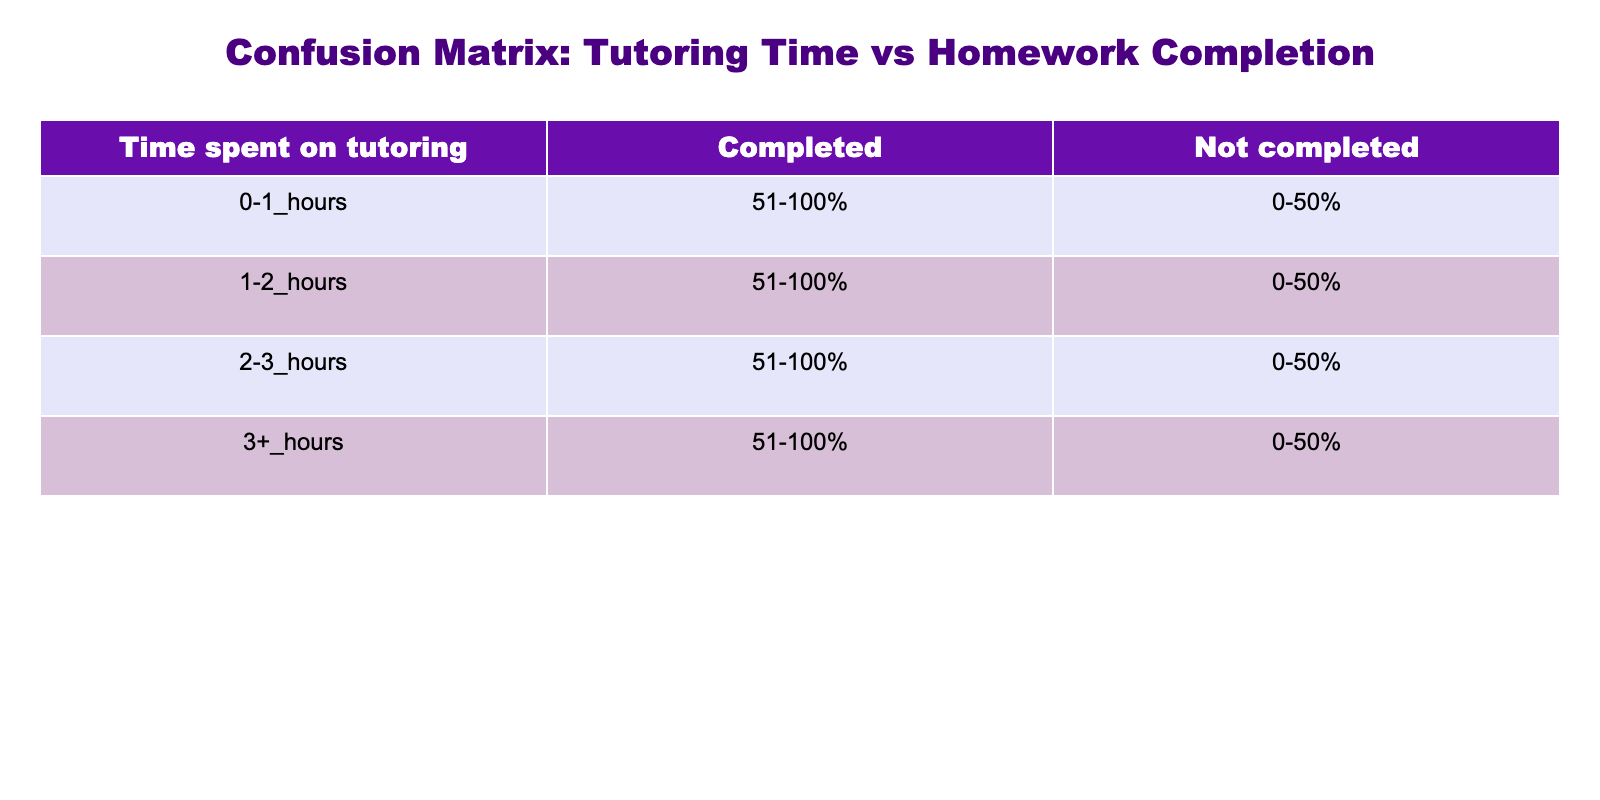What is the homework completion rate for those who spent 0-1 hours on tutoring? According to the table, for the time spent on tutoring of 0-1 hours, the completion rate shows "No" for 0-50% and "Yes" for 51-100%. Thus, the homework completion rates indicate that 0-1 hours of tutoring resulted in both completed and non-completed homework.
Answer: 0-50%: No, 51-100%: Yes How many time intervals have a 'Yes' for homework completion? By examining the table, we count the time intervals for which the Completed column has a 'Yes.' These intervals are for 0-1 hours (51-100%), 1-2 hours (51-100%), 2-3 hours (51-100%), and 3+ hours (51-100%). Therefore, there are four intervals.
Answer: 4 Is there any time spent on tutoring where homework was consistently not completed? The table indicates that for the time intervals of 0-1 hours, 1-2 hours, 2-3 hours, and 3+ hours, the completion rate for 0-50% is "No," confirming that these time slots indeed have instances of uncompleted homework. This indicates that homework was not completed in all these time intervals.
Answer: Yes What is the difference in homework completion rates between those who spent 1-2 hours and 2-3 hours on tutoring when comparing only the 'Yes' counts? From the table, both the 1-2 hours and 2-3 hours spent on tutoring have a 'Yes' completion rate for the 51-100% category. This shows there is no difference in those completing homework between these two time intervals since both show one 'Yes' response. Therefore, the difference is 0.
Answer: 0 If a student spends 3+ hours on tutoring, what can we infer about their homework completion rates? Based on the information in the table, for the students who spent 3+ hours, they can expect a high homework completion rate since the completion status shows a 'Yes' for 51-100%. Thus, it implies that spending more time on tutoring positively impacts homework completion.
Answer: High completion rate How many students did not complete their homework at the time interval of 0-1 hours? In looking at the table, for the time interval of 0-1 hours, under the Not_completed category, there is 'Yes' for 0-50% and 'No' for 51-100%. This means that there is one 'Yes' entry indicating students did not complete their homework at 0-1 hours.
Answer: 1 Was there any time interval where not a single homework was completed? The entries for 0-50% in the completed category across all time intervals indicate "No". Thus, it can be concluded that there is no time interval where homework was consistently completed as all intervals show at least one instance of not completing homework.
Answer: Yes What is the total number of 'No' entries for homework completion across all time intervals? To determine the total number of 'No' entries, review the table for each time interval. The 'No' entries are found under 0-50% for all four time intervals (0-1, 1-2, 2-3, and 3+ hours). Thus, we count four 'No' entries in total for homework completion across all intervals.
Answer: 4 